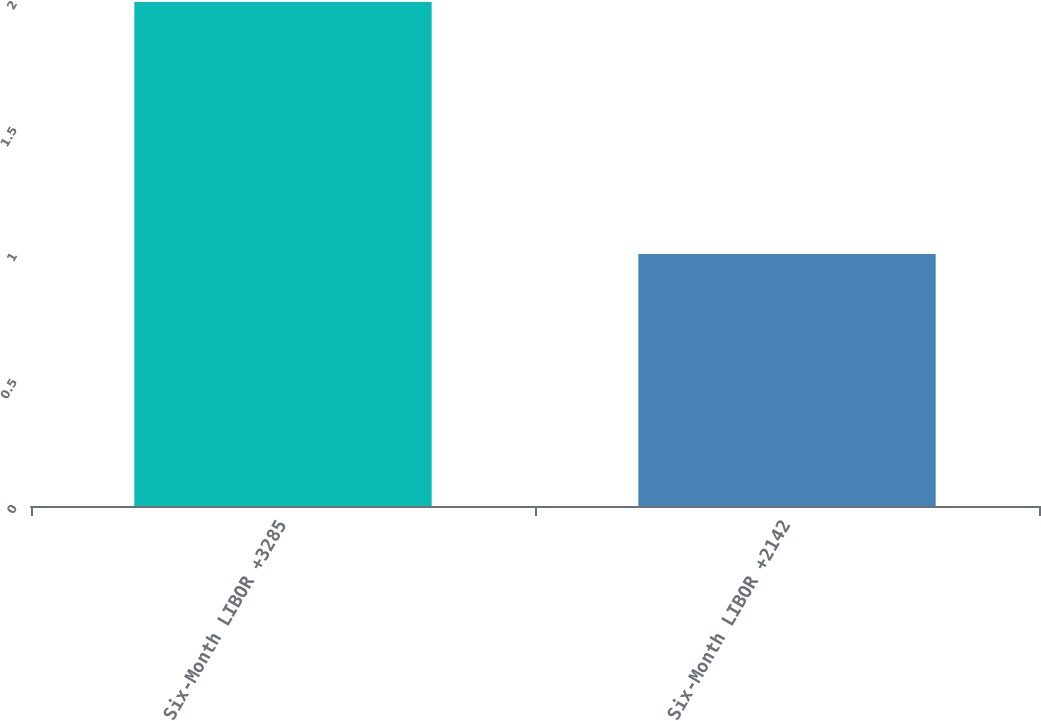<chart> <loc_0><loc_0><loc_500><loc_500><bar_chart><fcel>Six-Month LIBOR +3285<fcel>Six-Month LIBOR +2142<nl><fcel>2<fcel>1<nl></chart> 